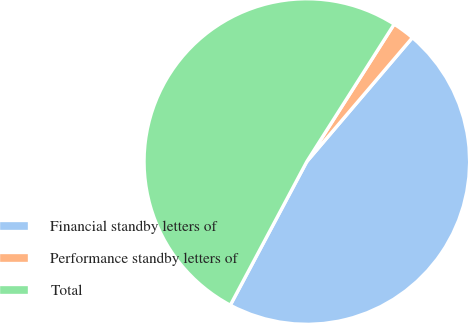<chart> <loc_0><loc_0><loc_500><loc_500><pie_chart><fcel>Financial standby letters of<fcel>Performance standby letters of<fcel>Total<nl><fcel>46.56%<fcel>2.22%<fcel>51.22%<nl></chart> 